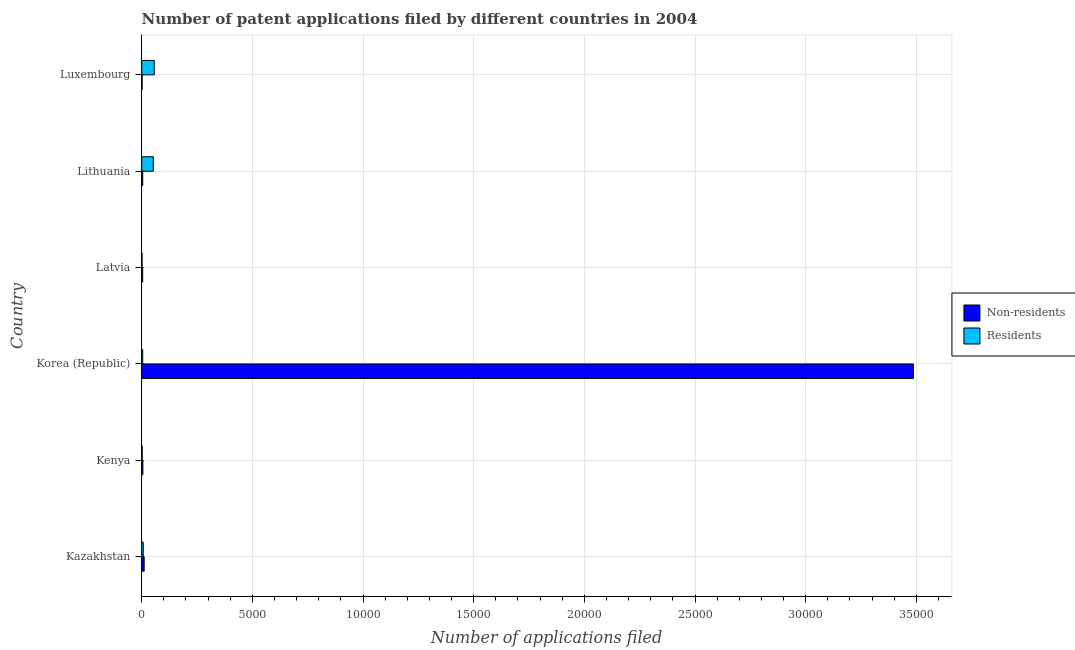Are the number of bars per tick equal to the number of legend labels?
Ensure brevity in your answer.  Yes. Are the number of bars on each tick of the Y-axis equal?
Provide a succinct answer. Yes. What is the label of the 3rd group of bars from the top?
Ensure brevity in your answer.  Latvia. What is the number of patent applications by residents in Lithuania?
Your answer should be very brief. 522. Across all countries, what is the maximum number of patent applications by non residents?
Give a very brief answer. 3.49e+04. Across all countries, what is the minimum number of patent applications by residents?
Offer a terse response. 16. In which country was the number of patent applications by residents maximum?
Your answer should be very brief. Luxembourg. In which country was the number of patent applications by residents minimum?
Make the answer very short. Latvia. What is the total number of patent applications by residents in the graph?
Offer a very short reply. 1240. What is the difference between the number of patent applications by non residents in Korea (Republic) and that in Luxembourg?
Offer a terse response. 3.48e+04. What is the difference between the number of patent applications by residents in Latvia and the number of patent applications by non residents in Kenya?
Offer a terse response. -37. What is the average number of patent applications by non residents per country?
Provide a short and direct response. 5855.67. What is the difference between the number of patent applications by non residents and number of patent applications by residents in Lithuania?
Keep it short and to the point. -478. In how many countries, is the number of patent applications by non residents greater than 31000 ?
Your answer should be very brief. 1. What is the ratio of the number of patent applications by residents in Kazakhstan to that in Kenya?
Ensure brevity in your answer.  3.04. Is the difference between the number of patent applications by non residents in Kenya and Korea (Republic) greater than the difference between the number of patent applications by residents in Kenya and Korea (Republic)?
Ensure brevity in your answer.  No. What is the difference between the highest and the second highest number of patent applications by non residents?
Offer a very short reply. 3.48e+04. What is the difference between the highest and the lowest number of patent applications by non residents?
Make the answer very short. 3.48e+04. Is the sum of the number of patent applications by residents in Korea (Republic) and Latvia greater than the maximum number of patent applications by non residents across all countries?
Your answer should be very brief. No. What does the 2nd bar from the top in Luxembourg represents?
Your answer should be very brief. Non-residents. What does the 1st bar from the bottom in Latvia represents?
Ensure brevity in your answer.  Non-residents. Are all the bars in the graph horizontal?
Keep it short and to the point. Yes. How many countries are there in the graph?
Keep it short and to the point. 6. What is the difference between two consecutive major ticks on the X-axis?
Provide a short and direct response. 5000. Are the values on the major ticks of X-axis written in scientific E-notation?
Offer a terse response. No. What is the title of the graph?
Keep it short and to the point. Number of patent applications filed by different countries in 2004. Does "National Tourists" appear as one of the legend labels in the graph?
Offer a very short reply. No. What is the label or title of the X-axis?
Your answer should be compact. Number of applications filed. What is the Number of applications filed in Non-residents in Kazakhstan?
Provide a succinct answer. 111. What is the Number of applications filed in Residents in Kazakhstan?
Ensure brevity in your answer.  70. What is the Number of applications filed of Non-residents in Korea (Republic)?
Give a very brief answer. 3.49e+04. What is the Number of applications filed in Residents in Korea (Republic)?
Your answer should be compact. 44. What is the Number of applications filed in Residents in Latvia?
Provide a succinct answer. 16. What is the Number of applications filed in Non-residents in Lithuania?
Provide a short and direct response. 44. What is the Number of applications filed in Residents in Lithuania?
Provide a short and direct response. 522. What is the Number of applications filed of Residents in Luxembourg?
Your answer should be very brief. 565. Across all countries, what is the maximum Number of applications filed in Non-residents?
Provide a succinct answer. 3.49e+04. Across all countries, what is the maximum Number of applications filed of Residents?
Provide a short and direct response. 565. Across all countries, what is the minimum Number of applications filed in Non-residents?
Offer a very short reply. 18. Across all countries, what is the minimum Number of applications filed in Residents?
Provide a succinct answer. 16. What is the total Number of applications filed of Non-residents in the graph?
Offer a very short reply. 3.51e+04. What is the total Number of applications filed in Residents in the graph?
Make the answer very short. 1240. What is the difference between the Number of applications filed in Non-residents in Kazakhstan and that in Kenya?
Make the answer very short. 58. What is the difference between the Number of applications filed of Residents in Kazakhstan and that in Kenya?
Ensure brevity in your answer.  47. What is the difference between the Number of applications filed in Non-residents in Kazakhstan and that in Korea (Republic)?
Your answer should be compact. -3.48e+04. What is the difference between the Number of applications filed in Residents in Kazakhstan and that in Lithuania?
Your answer should be very brief. -452. What is the difference between the Number of applications filed in Non-residents in Kazakhstan and that in Luxembourg?
Provide a short and direct response. 93. What is the difference between the Number of applications filed of Residents in Kazakhstan and that in Luxembourg?
Make the answer very short. -495. What is the difference between the Number of applications filed of Non-residents in Kenya and that in Korea (Republic)?
Your answer should be compact. -3.48e+04. What is the difference between the Number of applications filed of Residents in Kenya and that in Korea (Republic)?
Your answer should be very brief. -21. What is the difference between the Number of applications filed of Non-residents in Kenya and that in Latvia?
Keep it short and to the point. 10. What is the difference between the Number of applications filed of Residents in Kenya and that in Latvia?
Offer a terse response. 7. What is the difference between the Number of applications filed of Residents in Kenya and that in Lithuania?
Ensure brevity in your answer.  -499. What is the difference between the Number of applications filed in Non-residents in Kenya and that in Luxembourg?
Your response must be concise. 35. What is the difference between the Number of applications filed of Residents in Kenya and that in Luxembourg?
Offer a very short reply. -542. What is the difference between the Number of applications filed in Non-residents in Korea (Republic) and that in Latvia?
Your answer should be compact. 3.48e+04. What is the difference between the Number of applications filed in Non-residents in Korea (Republic) and that in Lithuania?
Offer a terse response. 3.48e+04. What is the difference between the Number of applications filed in Residents in Korea (Republic) and that in Lithuania?
Your answer should be very brief. -478. What is the difference between the Number of applications filed in Non-residents in Korea (Republic) and that in Luxembourg?
Your answer should be compact. 3.48e+04. What is the difference between the Number of applications filed of Residents in Korea (Republic) and that in Luxembourg?
Offer a terse response. -521. What is the difference between the Number of applications filed in Residents in Latvia and that in Lithuania?
Give a very brief answer. -506. What is the difference between the Number of applications filed of Residents in Latvia and that in Luxembourg?
Keep it short and to the point. -549. What is the difference between the Number of applications filed of Non-residents in Lithuania and that in Luxembourg?
Your answer should be very brief. 26. What is the difference between the Number of applications filed in Residents in Lithuania and that in Luxembourg?
Provide a succinct answer. -43. What is the difference between the Number of applications filed in Non-residents in Kazakhstan and the Number of applications filed in Residents in Kenya?
Offer a terse response. 88. What is the difference between the Number of applications filed of Non-residents in Kazakhstan and the Number of applications filed of Residents in Korea (Republic)?
Make the answer very short. 67. What is the difference between the Number of applications filed in Non-residents in Kazakhstan and the Number of applications filed in Residents in Latvia?
Provide a short and direct response. 95. What is the difference between the Number of applications filed in Non-residents in Kazakhstan and the Number of applications filed in Residents in Lithuania?
Offer a very short reply. -411. What is the difference between the Number of applications filed in Non-residents in Kazakhstan and the Number of applications filed in Residents in Luxembourg?
Offer a terse response. -454. What is the difference between the Number of applications filed of Non-residents in Kenya and the Number of applications filed of Residents in Lithuania?
Your response must be concise. -469. What is the difference between the Number of applications filed of Non-residents in Kenya and the Number of applications filed of Residents in Luxembourg?
Your answer should be compact. -512. What is the difference between the Number of applications filed in Non-residents in Korea (Republic) and the Number of applications filed in Residents in Latvia?
Keep it short and to the point. 3.48e+04. What is the difference between the Number of applications filed in Non-residents in Korea (Republic) and the Number of applications filed in Residents in Lithuania?
Give a very brief answer. 3.43e+04. What is the difference between the Number of applications filed of Non-residents in Korea (Republic) and the Number of applications filed of Residents in Luxembourg?
Offer a terse response. 3.43e+04. What is the difference between the Number of applications filed of Non-residents in Latvia and the Number of applications filed of Residents in Lithuania?
Your response must be concise. -479. What is the difference between the Number of applications filed of Non-residents in Latvia and the Number of applications filed of Residents in Luxembourg?
Offer a terse response. -522. What is the difference between the Number of applications filed of Non-residents in Lithuania and the Number of applications filed of Residents in Luxembourg?
Keep it short and to the point. -521. What is the average Number of applications filed of Non-residents per country?
Keep it short and to the point. 5855.67. What is the average Number of applications filed in Residents per country?
Provide a succinct answer. 206.67. What is the difference between the Number of applications filed of Non-residents and Number of applications filed of Residents in Korea (Republic)?
Give a very brief answer. 3.48e+04. What is the difference between the Number of applications filed in Non-residents and Number of applications filed in Residents in Lithuania?
Your answer should be compact. -478. What is the difference between the Number of applications filed of Non-residents and Number of applications filed of Residents in Luxembourg?
Keep it short and to the point. -547. What is the ratio of the Number of applications filed in Non-residents in Kazakhstan to that in Kenya?
Provide a short and direct response. 2.09. What is the ratio of the Number of applications filed of Residents in Kazakhstan to that in Kenya?
Offer a very short reply. 3.04. What is the ratio of the Number of applications filed in Non-residents in Kazakhstan to that in Korea (Republic)?
Your response must be concise. 0. What is the ratio of the Number of applications filed in Residents in Kazakhstan to that in Korea (Republic)?
Provide a succinct answer. 1.59. What is the ratio of the Number of applications filed in Non-residents in Kazakhstan to that in Latvia?
Ensure brevity in your answer.  2.58. What is the ratio of the Number of applications filed of Residents in Kazakhstan to that in Latvia?
Your answer should be compact. 4.38. What is the ratio of the Number of applications filed of Non-residents in Kazakhstan to that in Lithuania?
Your response must be concise. 2.52. What is the ratio of the Number of applications filed of Residents in Kazakhstan to that in Lithuania?
Ensure brevity in your answer.  0.13. What is the ratio of the Number of applications filed in Non-residents in Kazakhstan to that in Luxembourg?
Offer a terse response. 6.17. What is the ratio of the Number of applications filed in Residents in Kazakhstan to that in Luxembourg?
Keep it short and to the point. 0.12. What is the ratio of the Number of applications filed in Non-residents in Kenya to that in Korea (Republic)?
Your answer should be very brief. 0. What is the ratio of the Number of applications filed of Residents in Kenya to that in Korea (Republic)?
Keep it short and to the point. 0.52. What is the ratio of the Number of applications filed of Non-residents in Kenya to that in Latvia?
Make the answer very short. 1.23. What is the ratio of the Number of applications filed in Residents in Kenya to that in Latvia?
Your answer should be very brief. 1.44. What is the ratio of the Number of applications filed of Non-residents in Kenya to that in Lithuania?
Provide a succinct answer. 1.2. What is the ratio of the Number of applications filed in Residents in Kenya to that in Lithuania?
Ensure brevity in your answer.  0.04. What is the ratio of the Number of applications filed of Non-residents in Kenya to that in Luxembourg?
Provide a succinct answer. 2.94. What is the ratio of the Number of applications filed of Residents in Kenya to that in Luxembourg?
Provide a short and direct response. 0.04. What is the ratio of the Number of applications filed in Non-residents in Korea (Republic) to that in Latvia?
Ensure brevity in your answer.  810.81. What is the ratio of the Number of applications filed of Residents in Korea (Republic) to that in Latvia?
Provide a succinct answer. 2.75. What is the ratio of the Number of applications filed of Non-residents in Korea (Republic) to that in Lithuania?
Ensure brevity in your answer.  792.39. What is the ratio of the Number of applications filed in Residents in Korea (Republic) to that in Lithuania?
Provide a succinct answer. 0.08. What is the ratio of the Number of applications filed of Non-residents in Korea (Republic) to that in Luxembourg?
Provide a short and direct response. 1936.94. What is the ratio of the Number of applications filed of Residents in Korea (Republic) to that in Luxembourg?
Give a very brief answer. 0.08. What is the ratio of the Number of applications filed in Non-residents in Latvia to that in Lithuania?
Offer a terse response. 0.98. What is the ratio of the Number of applications filed of Residents in Latvia to that in Lithuania?
Offer a terse response. 0.03. What is the ratio of the Number of applications filed of Non-residents in Latvia to that in Luxembourg?
Offer a very short reply. 2.39. What is the ratio of the Number of applications filed in Residents in Latvia to that in Luxembourg?
Give a very brief answer. 0.03. What is the ratio of the Number of applications filed of Non-residents in Lithuania to that in Luxembourg?
Provide a succinct answer. 2.44. What is the ratio of the Number of applications filed in Residents in Lithuania to that in Luxembourg?
Provide a succinct answer. 0.92. What is the difference between the highest and the second highest Number of applications filed of Non-residents?
Make the answer very short. 3.48e+04. What is the difference between the highest and the second highest Number of applications filed in Residents?
Make the answer very short. 43. What is the difference between the highest and the lowest Number of applications filed of Non-residents?
Provide a short and direct response. 3.48e+04. What is the difference between the highest and the lowest Number of applications filed of Residents?
Provide a succinct answer. 549. 